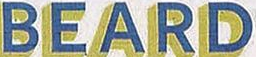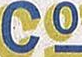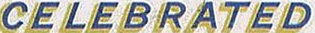Transcribe the words shown in these images in order, separated by a semicolon. BEARD; Co; CELEBRATED 